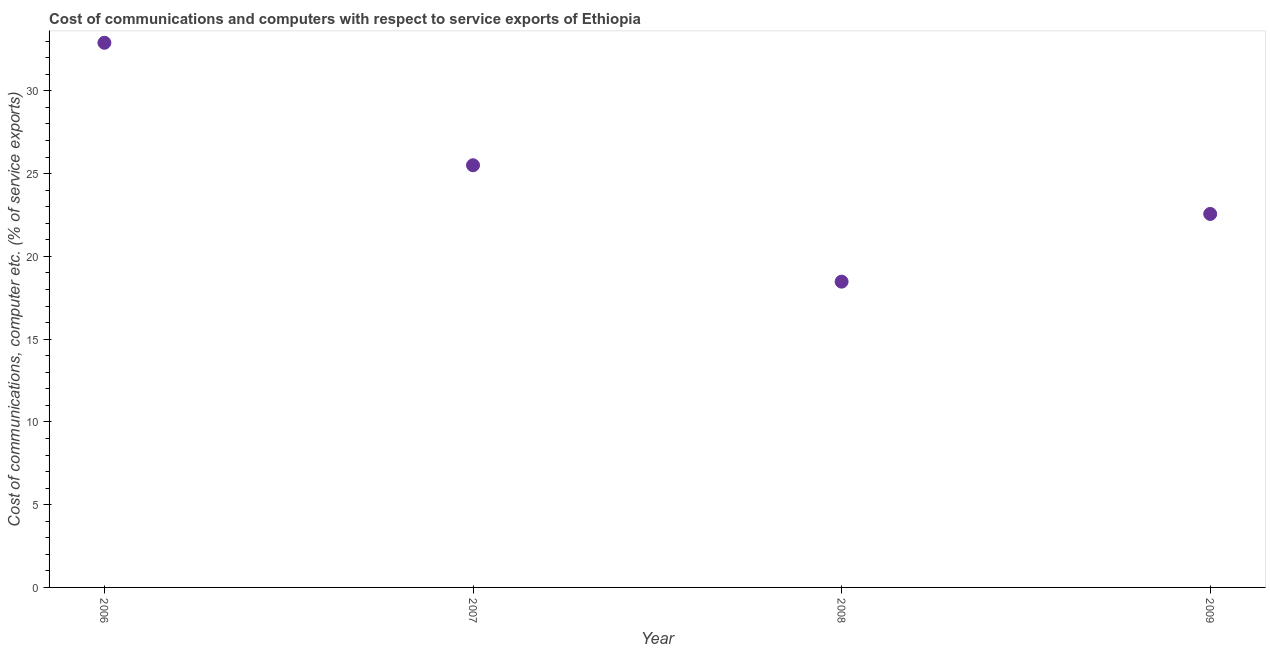What is the cost of communications and computer in 2008?
Provide a succinct answer. 18.47. Across all years, what is the maximum cost of communications and computer?
Provide a short and direct response. 32.91. Across all years, what is the minimum cost of communications and computer?
Make the answer very short. 18.47. What is the sum of the cost of communications and computer?
Your answer should be very brief. 99.45. What is the difference between the cost of communications and computer in 2008 and 2009?
Provide a short and direct response. -4.09. What is the average cost of communications and computer per year?
Provide a succinct answer. 24.86. What is the median cost of communications and computer?
Provide a succinct answer. 24.03. What is the ratio of the cost of communications and computer in 2007 to that in 2008?
Provide a short and direct response. 1.38. Is the difference between the cost of communications and computer in 2007 and 2009 greater than the difference between any two years?
Your answer should be very brief. No. What is the difference between the highest and the second highest cost of communications and computer?
Offer a terse response. 7.4. What is the difference between the highest and the lowest cost of communications and computer?
Offer a terse response. 14.43. In how many years, is the cost of communications and computer greater than the average cost of communications and computer taken over all years?
Make the answer very short. 2. Does the cost of communications and computer monotonically increase over the years?
Give a very brief answer. No. How many years are there in the graph?
Provide a short and direct response. 4. Does the graph contain any zero values?
Your answer should be very brief. No. Does the graph contain grids?
Ensure brevity in your answer.  No. What is the title of the graph?
Ensure brevity in your answer.  Cost of communications and computers with respect to service exports of Ethiopia. What is the label or title of the Y-axis?
Your response must be concise. Cost of communications, computer etc. (% of service exports). What is the Cost of communications, computer etc. (% of service exports) in 2006?
Make the answer very short. 32.91. What is the Cost of communications, computer etc. (% of service exports) in 2007?
Offer a very short reply. 25.51. What is the Cost of communications, computer etc. (% of service exports) in 2008?
Your answer should be very brief. 18.47. What is the Cost of communications, computer etc. (% of service exports) in 2009?
Offer a terse response. 22.56. What is the difference between the Cost of communications, computer etc. (% of service exports) in 2006 and 2007?
Ensure brevity in your answer.  7.4. What is the difference between the Cost of communications, computer etc. (% of service exports) in 2006 and 2008?
Provide a short and direct response. 14.43. What is the difference between the Cost of communications, computer etc. (% of service exports) in 2006 and 2009?
Your answer should be very brief. 10.34. What is the difference between the Cost of communications, computer etc. (% of service exports) in 2007 and 2008?
Offer a terse response. 7.03. What is the difference between the Cost of communications, computer etc. (% of service exports) in 2007 and 2009?
Provide a short and direct response. 2.94. What is the difference between the Cost of communications, computer etc. (% of service exports) in 2008 and 2009?
Keep it short and to the point. -4.09. What is the ratio of the Cost of communications, computer etc. (% of service exports) in 2006 to that in 2007?
Provide a succinct answer. 1.29. What is the ratio of the Cost of communications, computer etc. (% of service exports) in 2006 to that in 2008?
Offer a very short reply. 1.78. What is the ratio of the Cost of communications, computer etc. (% of service exports) in 2006 to that in 2009?
Your answer should be very brief. 1.46. What is the ratio of the Cost of communications, computer etc. (% of service exports) in 2007 to that in 2008?
Ensure brevity in your answer.  1.38. What is the ratio of the Cost of communications, computer etc. (% of service exports) in 2007 to that in 2009?
Keep it short and to the point. 1.13. What is the ratio of the Cost of communications, computer etc. (% of service exports) in 2008 to that in 2009?
Offer a terse response. 0.82. 